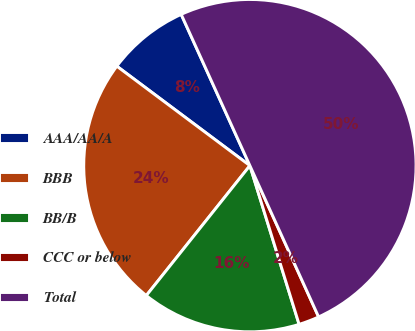Convert chart. <chart><loc_0><loc_0><loc_500><loc_500><pie_chart><fcel>AAA/AA/A<fcel>BBB<fcel>BB/B<fcel>CCC or below<fcel>Total<nl><fcel>8.0%<fcel>24.5%<fcel>15.5%<fcel>2.0%<fcel>50.0%<nl></chart> 